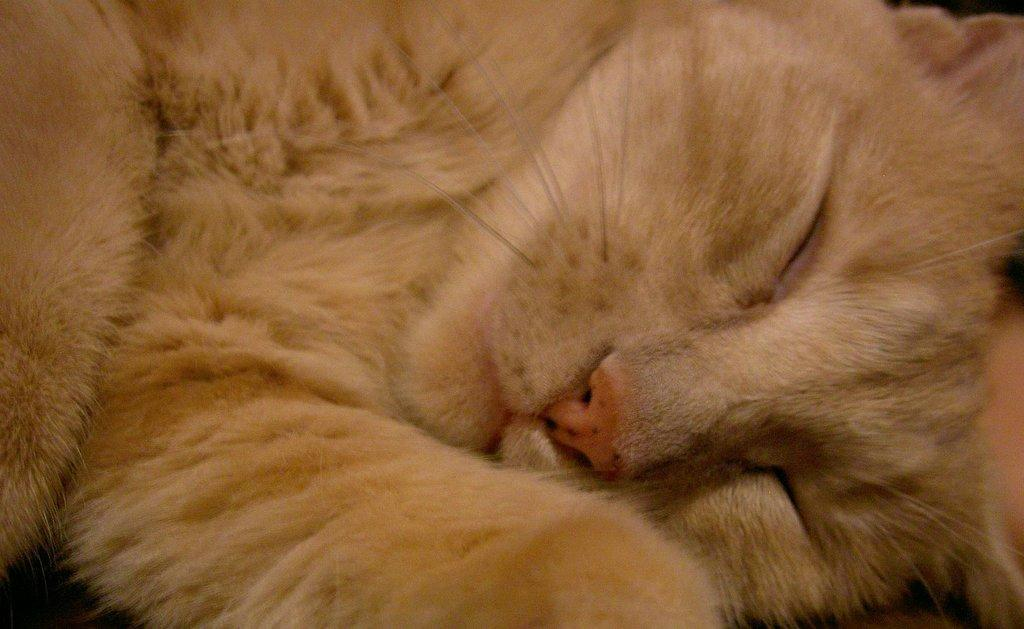What type of animal is present in the image? There is a cat in the image. What is the cat doing in the image? The cat is sleeping. What flavor of ice cream is the cat enjoying in the image? There is no ice cream present in the image, and the cat is not eating or enjoying any ice cream. 